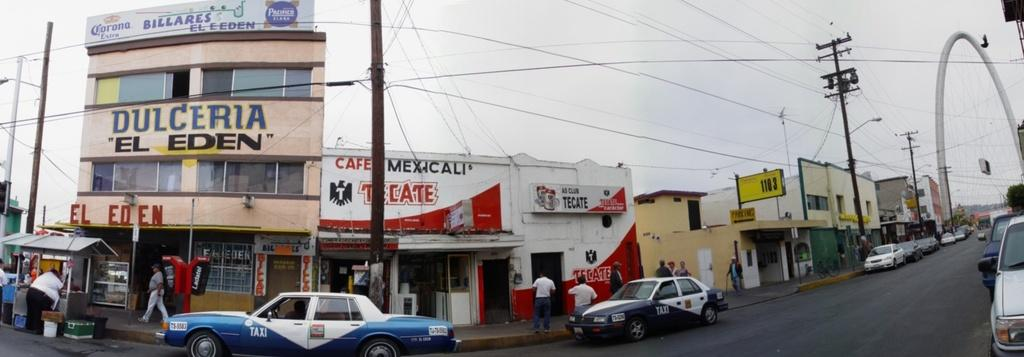<image>
Relay a brief, clear account of the picture shown. Two blue and white police cars are parked in front of a cafe with the signage cafe mexicali. 